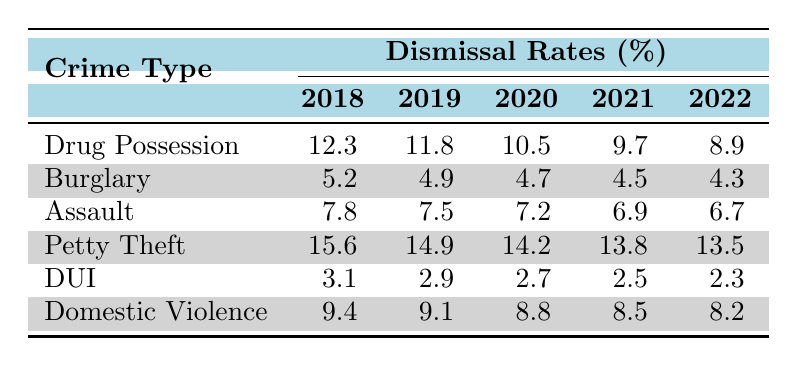What was the dismissal rate for Drug Possession in 2020? The table shows that the dismissal rate for Drug Possession in 2020 is 10.5%.
Answer: 10.5% Which crime type had the highest dismissal rate in 2018? According to the table, Petty Theft had the highest dismissal rate in 2018 at 15.6%.
Answer: Petty Theft Was there a decrease in the dismissal rate for DUI from 2018 to 2022? By comparing the values from the table, the dismissal rate for DUI decreased from 3.1% in 2018 to 2.3% in 2022, indicating a decrease.
Answer: Yes What is the average dismissal rate for Assault over the years listed? The dismissal rates for Assault from 2018 to 2022 are 7.8, 7.5, 7.2, 6.9, and 6.7. Summing these gives 36.1, and dividing by 5 results in an average of 7.22%.
Answer: 7.22% Which crime type showed the least decrease in dismissal rates from 2018 to 2022? Looking at the table, Drug Possession saw a decrease of 3.4% (from 12.3% to 8.9%), while Burglary only decreased by 0.9% (from 5.2% to 4.3%). Burglary had the least decrease.
Answer: Burglary What was the dismissal rate for Domestic Violence in 2019? The table indicates that the dismissal rate for Domestic Violence in 2019 is 9.1%.
Answer: 9.1% What is the total decrease in dismissal rates for Petty Theft from 2018 to 2022? The dismissal rate for Petty Theft decreased from 15.6% in 2018 to 13.5% in 2022. The total decrease is 15.6 - 13.5 = 2.1%.
Answer: 2.1% Is the dismissal rate for Drug Possession consistently decreasing each year? By examining the table, it shows a consistent decrease in Drug Possession rates each year: 12.3%, 11.8%, 10.5%, 9.7%, and 8.9%.
Answer: Yes Which crime type had a lower dismissal rate in 2021, DUI or Domestic Violence? The table shows that DUI had a dismissal rate of 2.5% in 2021, while Domestic Violence had a dismissal rate of 8.5%. Therefore, DUI had a lower dismissal rate.
Answer: DUI What was the difference in dismissal rates between the highest and lowest for 2022? In 2022, Petty Theft had a dismissal rate of 13.5% and DUI had a rate of 2.3%. The difference is 13.5 - 2.3 = 11.2%.
Answer: 11.2% How did the dismissal rates for Assault compare to those for Domestic Violence in 2020? In 2020, the dismissal rate for Assault was 7.2% while for Domestic Violence it was 8.8%. Domestic Violence had a higher rate than Assault.
Answer: Domestic Violence had a higher rate 